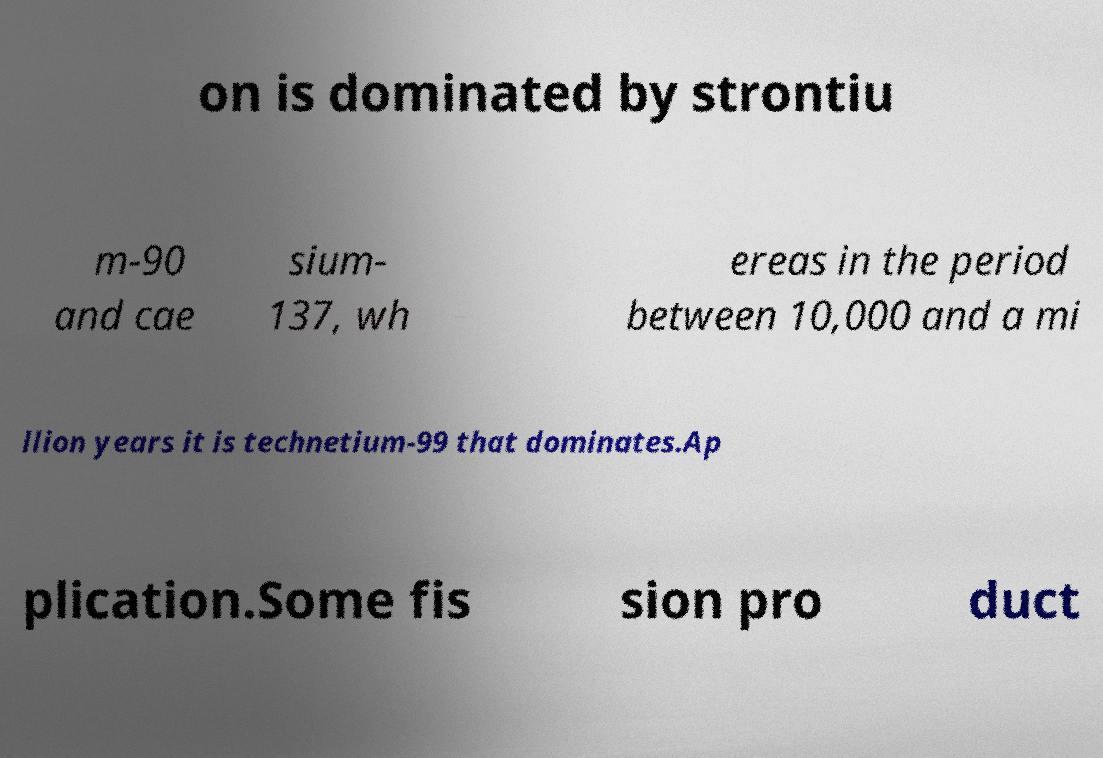Could you extract and type out the text from this image? on is dominated by strontiu m-90 and cae sium- 137, wh ereas in the period between 10,000 and a mi llion years it is technetium-99 that dominates.Ap plication.Some fis sion pro duct 